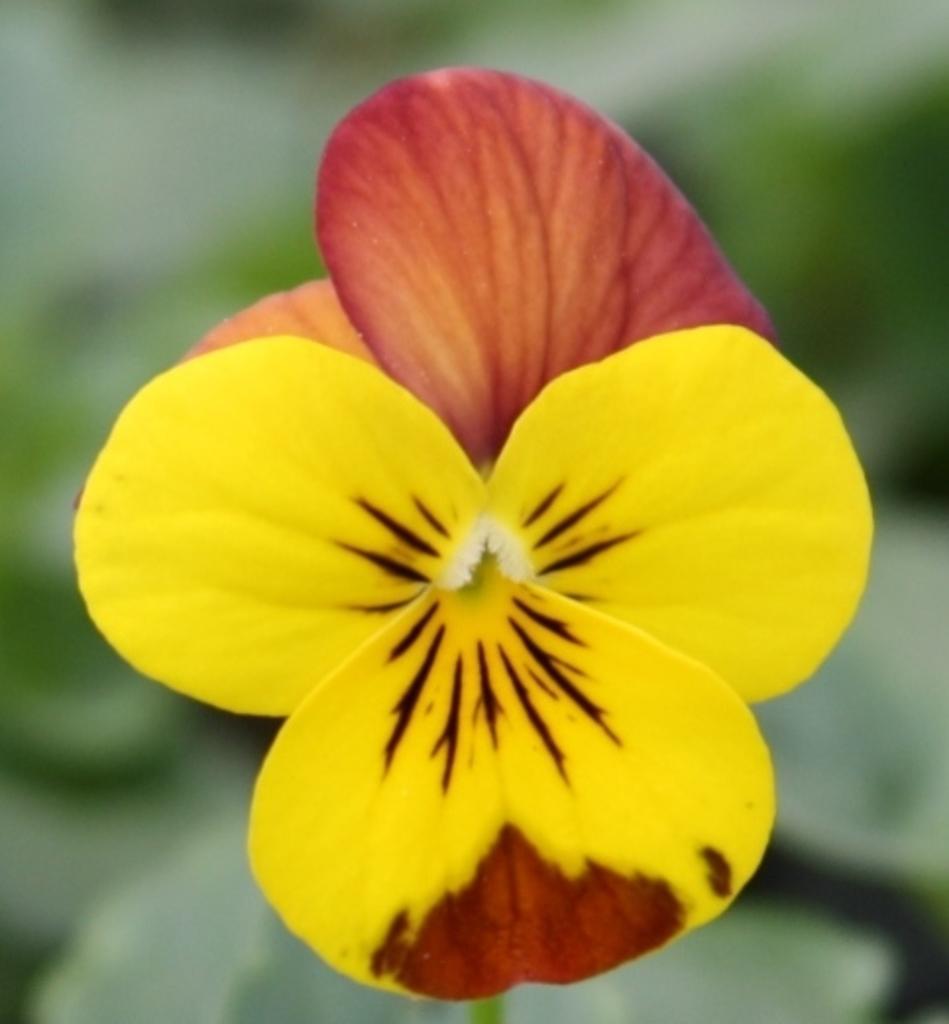In one or two sentences, can you explain what this image depicts? In this image we can see a flower and blur background. 